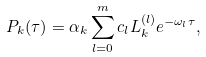<formula> <loc_0><loc_0><loc_500><loc_500>P _ { k } ( \tau ) = \alpha _ { k } \sum _ { l = 0 } ^ { m } c _ { l } L _ { k } ^ { ( l ) } e ^ { - \omega _ { l } \tau } ,</formula> 